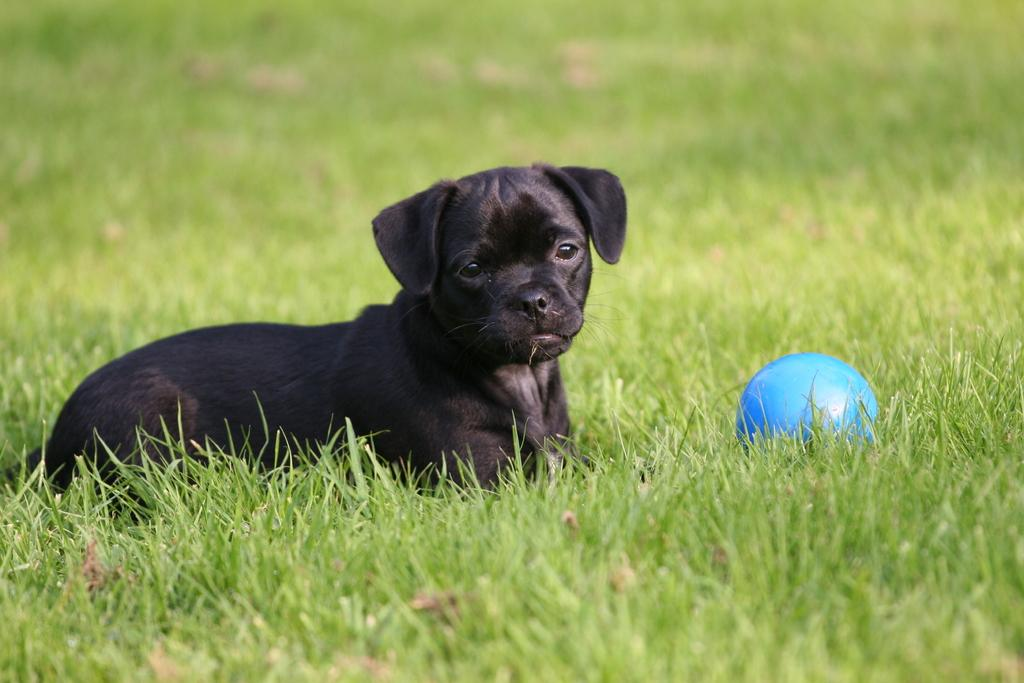What animal is present in the image? There is a dog in the image. What object is with the dog in the image? There is a ball in the image. Where are the dog and ball located? The dog and ball are on green grass. Can you describe the background of the image? The background of the image is blurry. How many stars can be seen in the image? There are no stars visible in the image. What fact is being presented in the image? The image does not present any specific fact; it simply shows a dog and a ball on green grass with a blurry background. 